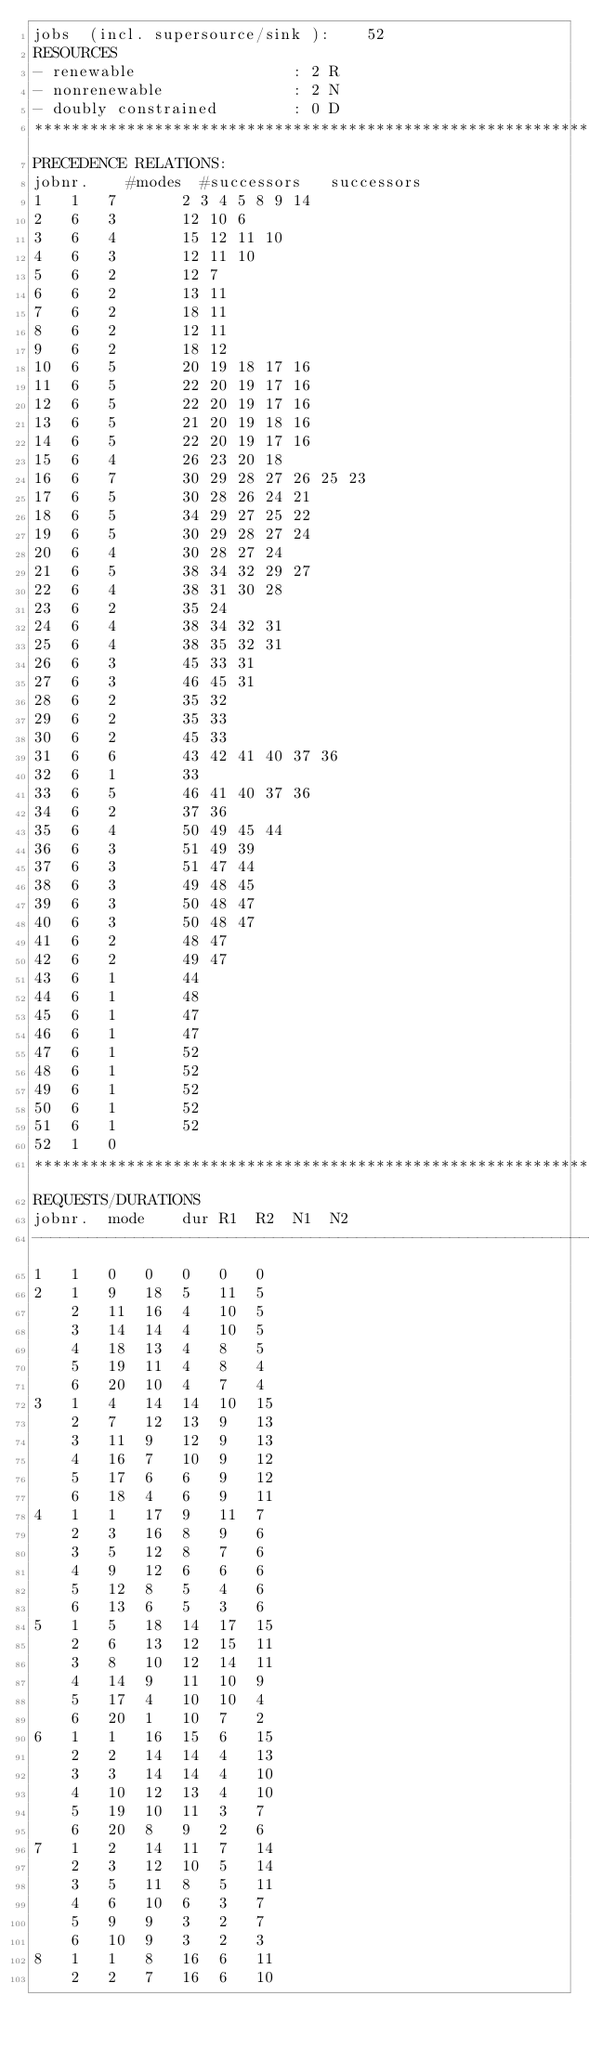<code> <loc_0><loc_0><loc_500><loc_500><_ObjectiveC_>jobs  (incl. supersource/sink ):	52
RESOURCES
- renewable                 : 2 R
- nonrenewable              : 2 N
- doubly constrained        : 0 D
************************************************************************
PRECEDENCE RELATIONS:
jobnr.    #modes  #successors   successors
1	1	7		2 3 4 5 8 9 14 
2	6	3		12 10 6 
3	6	4		15 12 11 10 
4	6	3		12 11 10 
5	6	2		12 7 
6	6	2		13 11 
7	6	2		18 11 
8	6	2		12 11 
9	6	2		18 12 
10	6	5		20 19 18 17 16 
11	6	5		22 20 19 17 16 
12	6	5		22 20 19 17 16 
13	6	5		21 20 19 18 16 
14	6	5		22 20 19 17 16 
15	6	4		26 23 20 18 
16	6	7		30 29 28 27 26 25 23 
17	6	5		30 28 26 24 21 
18	6	5		34 29 27 25 22 
19	6	5		30 29 28 27 24 
20	6	4		30 28 27 24 
21	6	5		38 34 32 29 27 
22	6	4		38 31 30 28 
23	6	2		35 24 
24	6	4		38 34 32 31 
25	6	4		38 35 32 31 
26	6	3		45 33 31 
27	6	3		46 45 31 
28	6	2		35 32 
29	6	2		35 33 
30	6	2		45 33 
31	6	6		43 42 41 40 37 36 
32	6	1		33 
33	6	5		46 41 40 37 36 
34	6	2		37 36 
35	6	4		50 49 45 44 
36	6	3		51 49 39 
37	6	3		51 47 44 
38	6	3		49 48 45 
39	6	3		50 48 47 
40	6	3		50 48 47 
41	6	2		48 47 
42	6	2		49 47 
43	6	1		44 
44	6	1		48 
45	6	1		47 
46	6	1		47 
47	6	1		52 
48	6	1		52 
49	6	1		52 
50	6	1		52 
51	6	1		52 
52	1	0		
************************************************************************
REQUESTS/DURATIONS
jobnr.	mode	dur	R1	R2	N1	N2	
------------------------------------------------------------------------
1	1	0	0	0	0	0	
2	1	9	18	5	11	5	
	2	11	16	4	10	5	
	3	14	14	4	10	5	
	4	18	13	4	8	5	
	5	19	11	4	8	4	
	6	20	10	4	7	4	
3	1	4	14	14	10	15	
	2	7	12	13	9	13	
	3	11	9	12	9	13	
	4	16	7	10	9	12	
	5	17	6	6	9	12	
	6	18	4	6	9	11	
4	1	1	17	9	11	7	
	2	3	16	8	9	6	
	3	5	12	8	7	6	
	4	9	12	6	6	6	
	5	12	8	5	4	6	
	6	13	6	5	3	6	
5	1	5	18	14	17	15	
	2	6	13	12	15	11	
	3	8	10	12	14	11	
	4	14	9	11	10	9	
	5	17	4	10	10	4	
	6	20	1	10	7	2	
6	1	1	16	15	6	15	
	2	2	14	14	4	13	
	3	3	14	14	4	10	
	4	10	12	13	4	10	
	5	19	10	11	3	7	
	6	20	8	9	2	6	
7	1	2	14	11	7	14	
	2	3	12	10	5	14	
	3	5	11	8	5	11	
	4	6	10	6	3	7	
	5	9	9	3	2	7	
	6	10	9	3	2	3	
8	1	1	8	16	6	11	
	2	2	7	16	6	10	</code> 